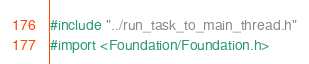<code> <loc_0><loc_0><loc_500><loc_500><_ObjectiveC_>
#include "../run_task_to_main_thread.h"
#import <Foundation/Foundation.h></code> 